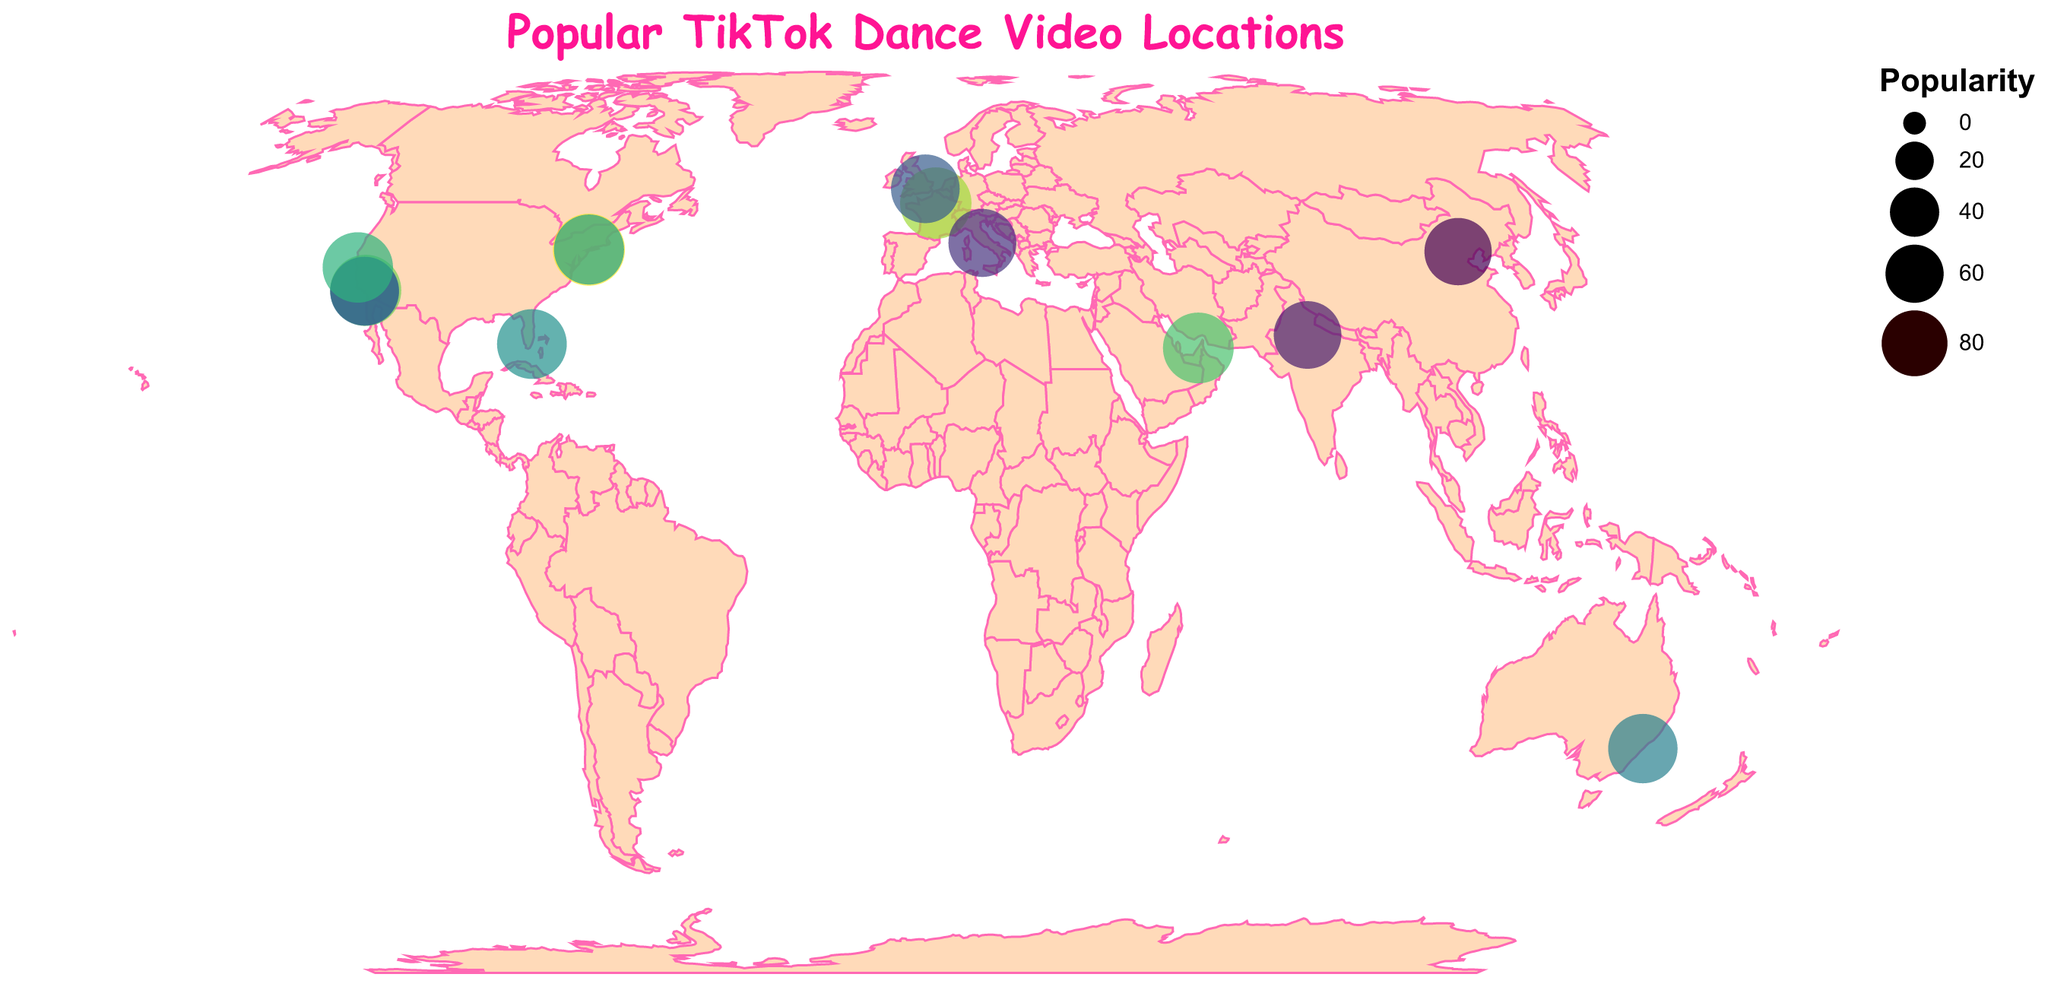What is the title of the figure? The figure's title is displayed prominently at the top of the plot. It reads "Popular TikTok Dance Video Locations" in Comic Sans MS font with a color of #FF1493.
Answer: Popular TikTok Dance Video Locations How many locations are plotted on the map? By counting the circles representing the locations on the map, you will find there are 14 locations marked.
Answer: 14 Which location has the highest popularity? From the provided data, Times Square has the highest popularity with a value of 98. This can be verified by looking at the size and color of the circles on the figure where Times Square appears larger and more prominently colored.
Answer: Times Square What is the difference in popularity between the Burj Khalifa and the Hollywood Sign? The popularity of the Burj Khalifa is 94, while the Hollywood Sign is 95. The difference is calculated as 95 - 94 = 1.
Answer: 1 Which location is more popular, the Golden Gate Bridge or the Sydney Opera House? The Golden Gate Bridge has a popularity of 93 whereas the Sydney Opera House has a popularity of 90. Therefore, the Golden Gate Bridge is more popular.
Answer: Golden Gate Bridge What are the latitude and longitude of the Taj Mahal? According to the provided data, the Taj Mahal is located at latitude 27.1751 and longitude 78.0421.
Answer: 27.1751, 78.0421 What is the least popular location shown on the map? The least popular location based on the given data is the Great Wall of China, with a popularity of 84.
Answer: Great Wall of China Does Miami Beach have higher popularity than Venice Beach Boardwalk? Miami Beach has a popularity of 91, whereas Venice Beach Boardwalk has a popularity of 89. Hence, Miami Beach's popularity is higher.
Answer: Yes How many locations have a popularity greater than 90? By looking at the popularity values provided, 7 locations have popularity values greater than 90: Hollywood Sign, Times Square, Central Park, Golden Gate Bridge, Miami Beach, Eiffel Tower, and Burj Khalifa.
Answer: 7 Which European landmarks are included in the map? From the data, the European landmarks included are the Eiffel Tower (France), Buckingham Palace (UK), and the Colosseum (Italy).
Answer: Eiffel Tower, Buckingham Palace, Colosseum 